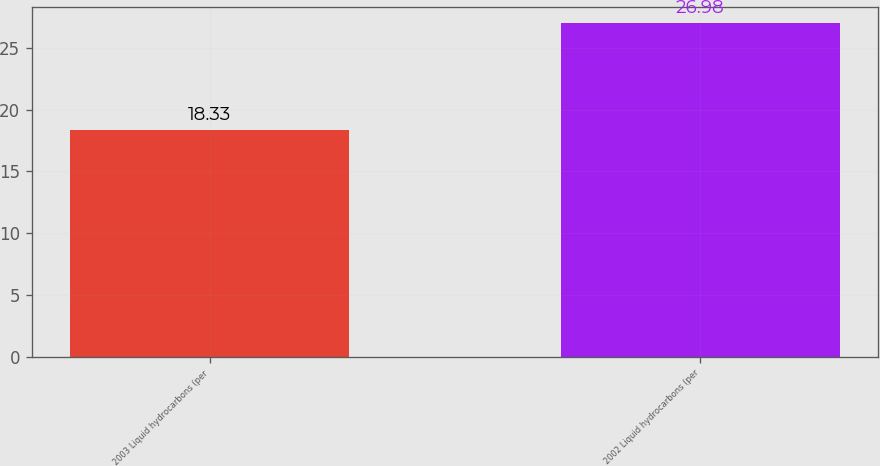<chart> <loc_0><loc_0><loc_500><loc_500><bar_chart><fcel>2003 Liquid hydrocarbons (per<fcel>2002 Liquid hydrocarbons (per<nl><fcel>18.33<fcel>26.98<nl></chart> 